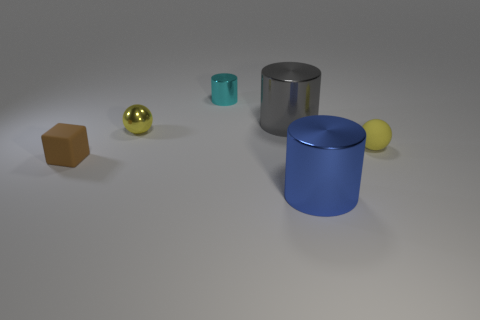Add 2 big brown blocks. How many objects exist? 8 Subtract all balls. How many objects are left? 4 Add 2 small matte balls. How many small matte balls are left? 3 Add 4 big gray things. How many big gray things exist? 5 Subtract 0 green cylinders. How many objects are left? 6 Subtract all blue cylinders. Subtract all spheres. How many objects are left? 3 